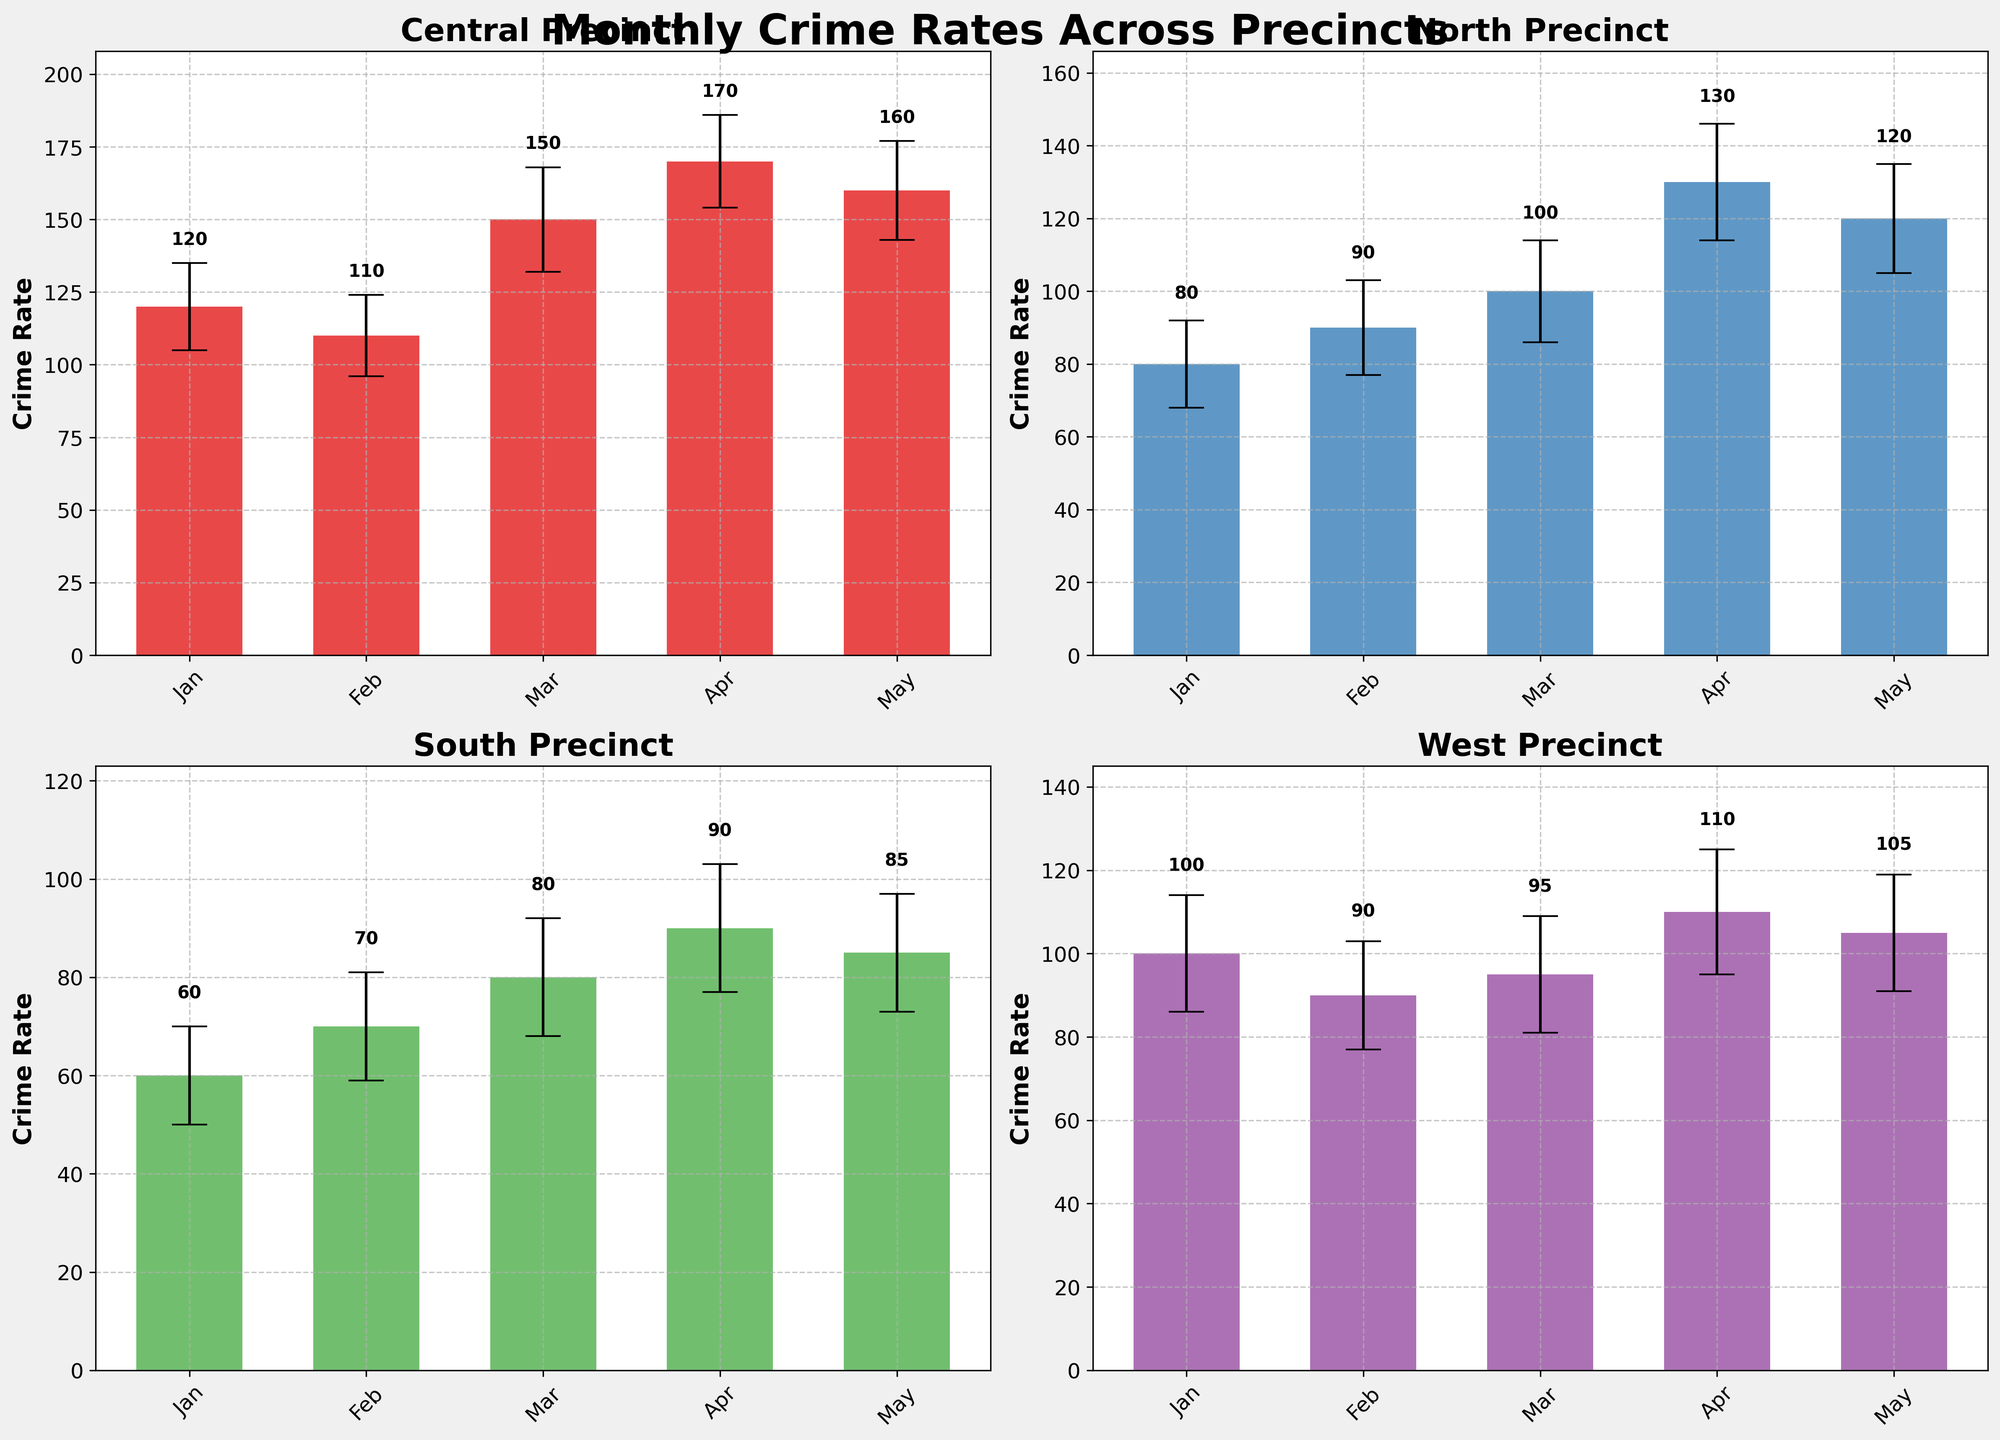Which precinct has the highest crime rate in May? The figure shows monthly crime rates for each precinct. By looking at the May data across the subplots, you can see that the Central precinct has the highest crime rate with a value of 160.
Answer: Central Which precinct has the lowest crime rate in January? The figure shows monthly crime rates for each precinct. By comparing the January values, the South precinct has the lowest crime rate with a value of 60.
Answer: South What is the overall trend in crime rates in the North precinct from January to May? To identify the trend, observe the bars for the North precinct from January to May. The crime rates are as follows: 80, 90, 100, 130, 120. The trend shows an overall increase from January to April and a slight decrease in May.
Answer: Increasing until April, then decreasing in May How does the crime rate in Central precinct in February compare with the crime rate in the West precinct in the same month? Compare the February crime rates of the Central and West precincts. Central has 110, while West has 90, indicating Central has a higher crime rate in February.
Answer: Central is higher Which month shows the most significant increase in crime rate in the Central precinct? To find the most significant increase, compare the differences between consecutive months in the Central precinct plot. The most significant increase is from February (110) to March (150), a difference of 40.
Answer: February to March Which precinct has the smallest variation in crime rate from January to May? To determine the smallest variation, look at the differences between the highest and lowest crime rates for each precinct. South precinct shows the smallest range (90 in April to 60 in January) which is 30.
Answer: South What is the range of crime rates in the West precinct for the given months? To find the range, subtract the lowest crime rate from the highest in the West precinct: highest (110 in April) and lowest (90 in February). The range is 20.
Answer: 20 What can be inferred about the error bars for the crime rates in the South precinct? Notice the size of the error bars for each bar in the South precinct subplot. They are consistently small, suggesting lower variability or uncertainty in the crime rate measurements.
Answer: Small variability Which precinct shows a decreasing trend in crime rates from April to May? Examine the crime rates in April and May for each precinct. Only the North precinct shows a decrease from 130 in April to 120 in May.
Answer: North Do any precincts have the same crime rate for more than one month? Check each precinct's subplot to see if any months have the same bar height. No precinct shows the same value for more than one month.
Answer: No 